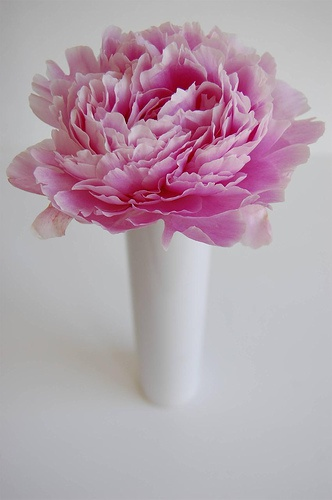Describe the objects in this image and their specific colors. I can see a vase in darkgray, lightgray, and gray tones in this image. 